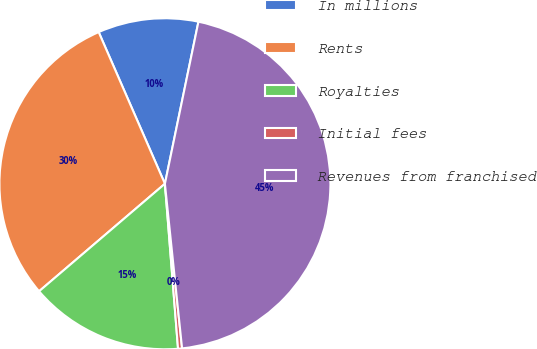Convert chart. <chart><loc_0><loc_0><loc_500><loc_500><pie_chart><fcel>In millions<fcel>Rents<fcel>Royalties<fcel>Initial fees<fcel>Revenues from franchised<nl><fcel>9.8%<fcel>29.7%<fcel>15.01%<fcel>0.39%<fcel>45.1%<nl></chart> 